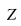<formula> <loc_0><loc_0><loc_500><loc_500>Z</formula> 